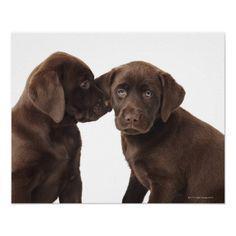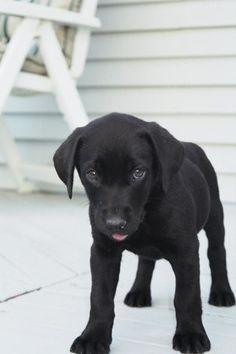The first image is the image on the left, the second image is the image on the right. Evaluate the accuracy of this statement regarding the images: "One image shows a single black dog and the other shows a pair of brown dogs.". Is it true? Answer yes or no. Yes. 